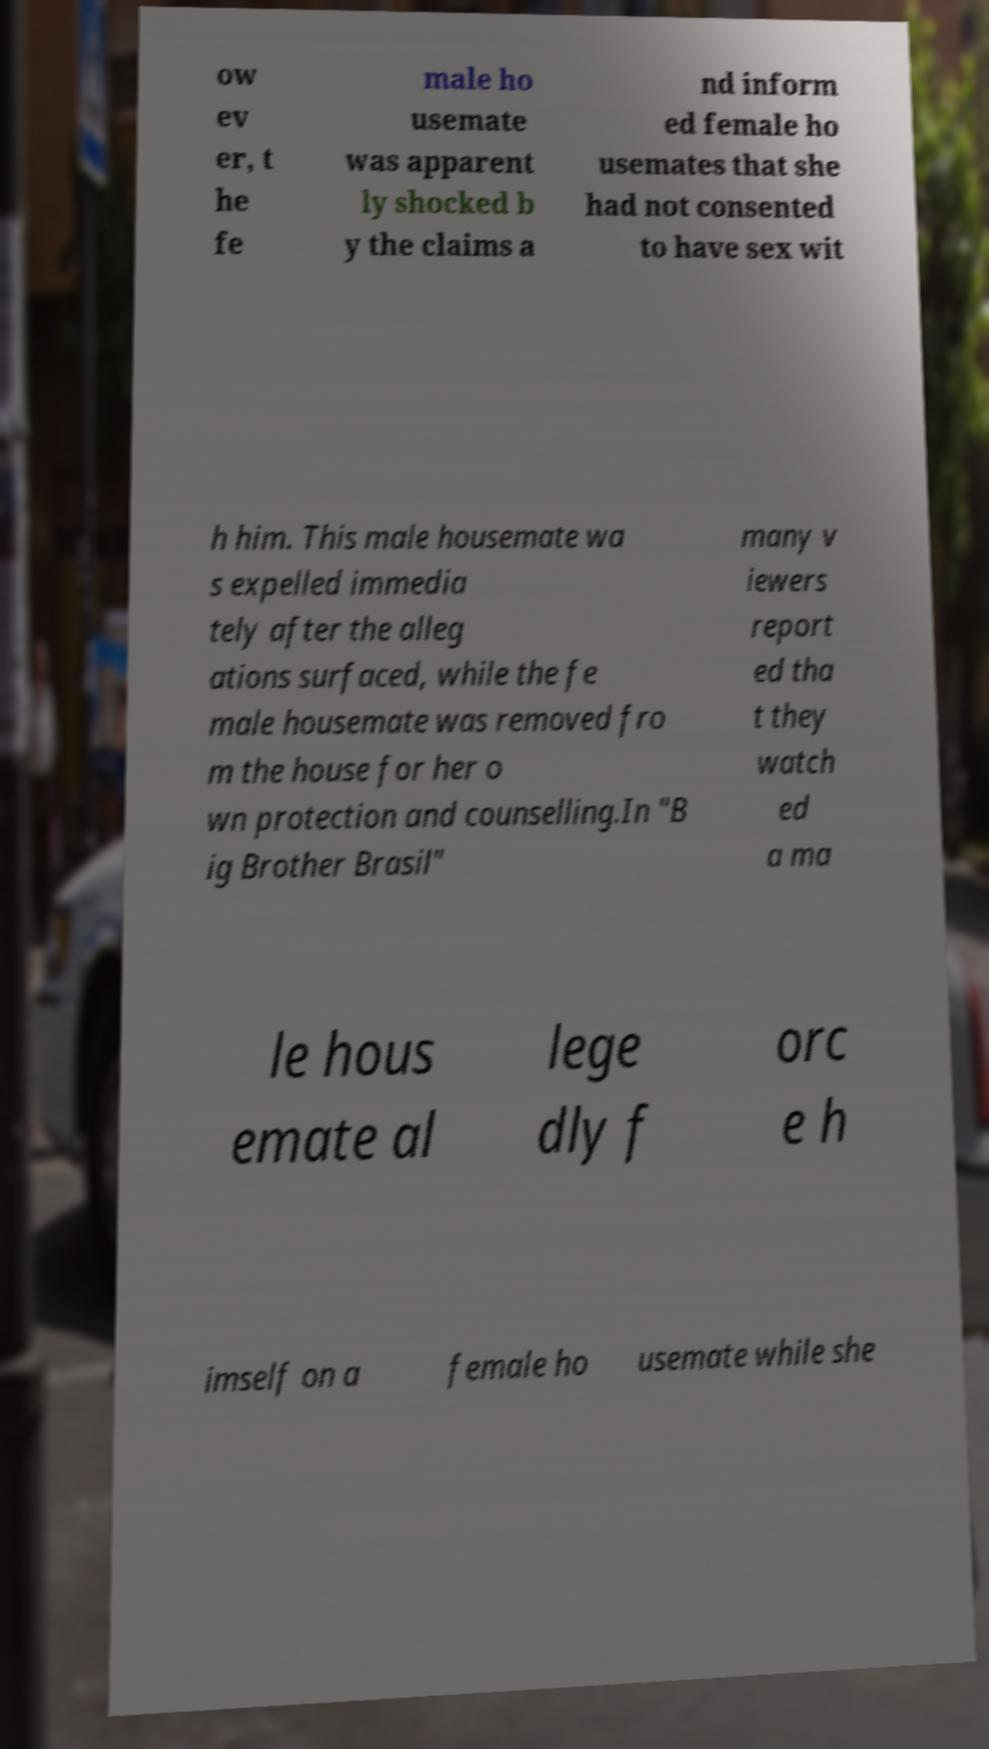For documentation purposes, I need the text within this image transcribed. Could you provide that? ow ev er, t he fe male ho usemate was apparent ly shocked b y the claims a nd inform ed female ho usemates that she had not consented to have sex wit h him. This male housemate wa s expelled immedia tely after the alleg ations surfaced, while the fe male housemate was removed fro m the house for her o wn protection and counselling.In "B ig Brother Brasil" many v iewers report ed tha t they watch ed a ma le hous emate al lege dly f orc e h imself on a female ho usemate while she 